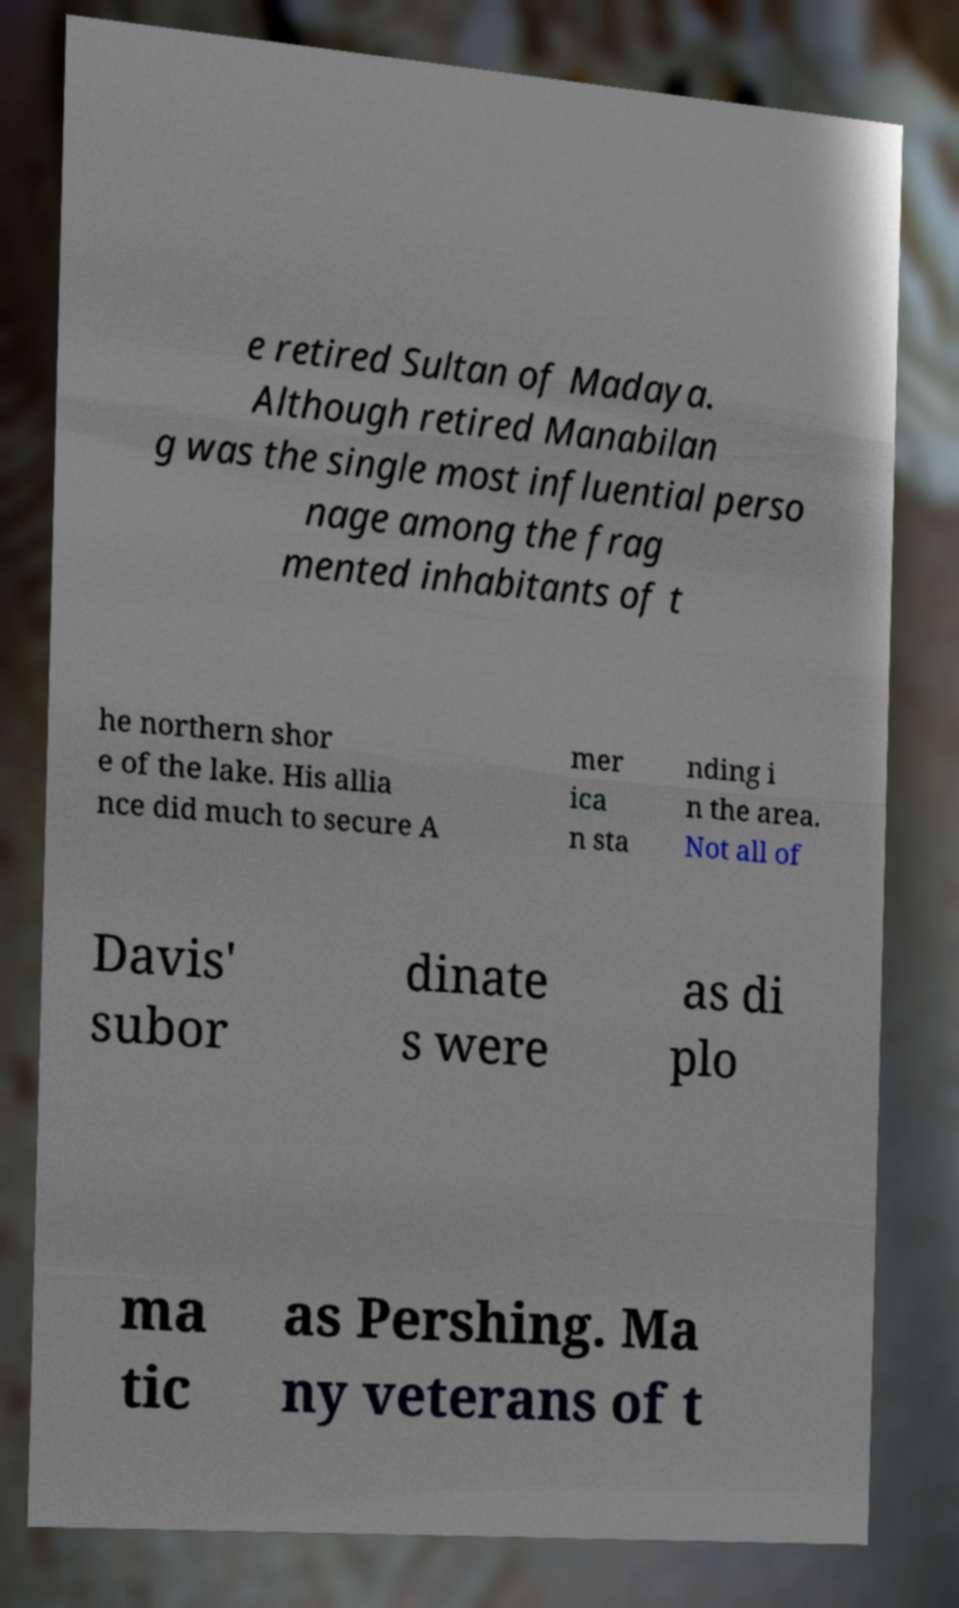There's text embedded in this image that I need extracted. Can you transcribe it verbatim? e retired Sultan of Madaya. Although retired Manabilan g was the single most influential perso nage among the frag mented inhabitants of t he northern shor e of the lake. His allia nce did much to secure A mer ica n sta nding i n the area. Not all of Davis' subor dinate s were as di plo ma tic as Pershing. Ma ny veterans of t 